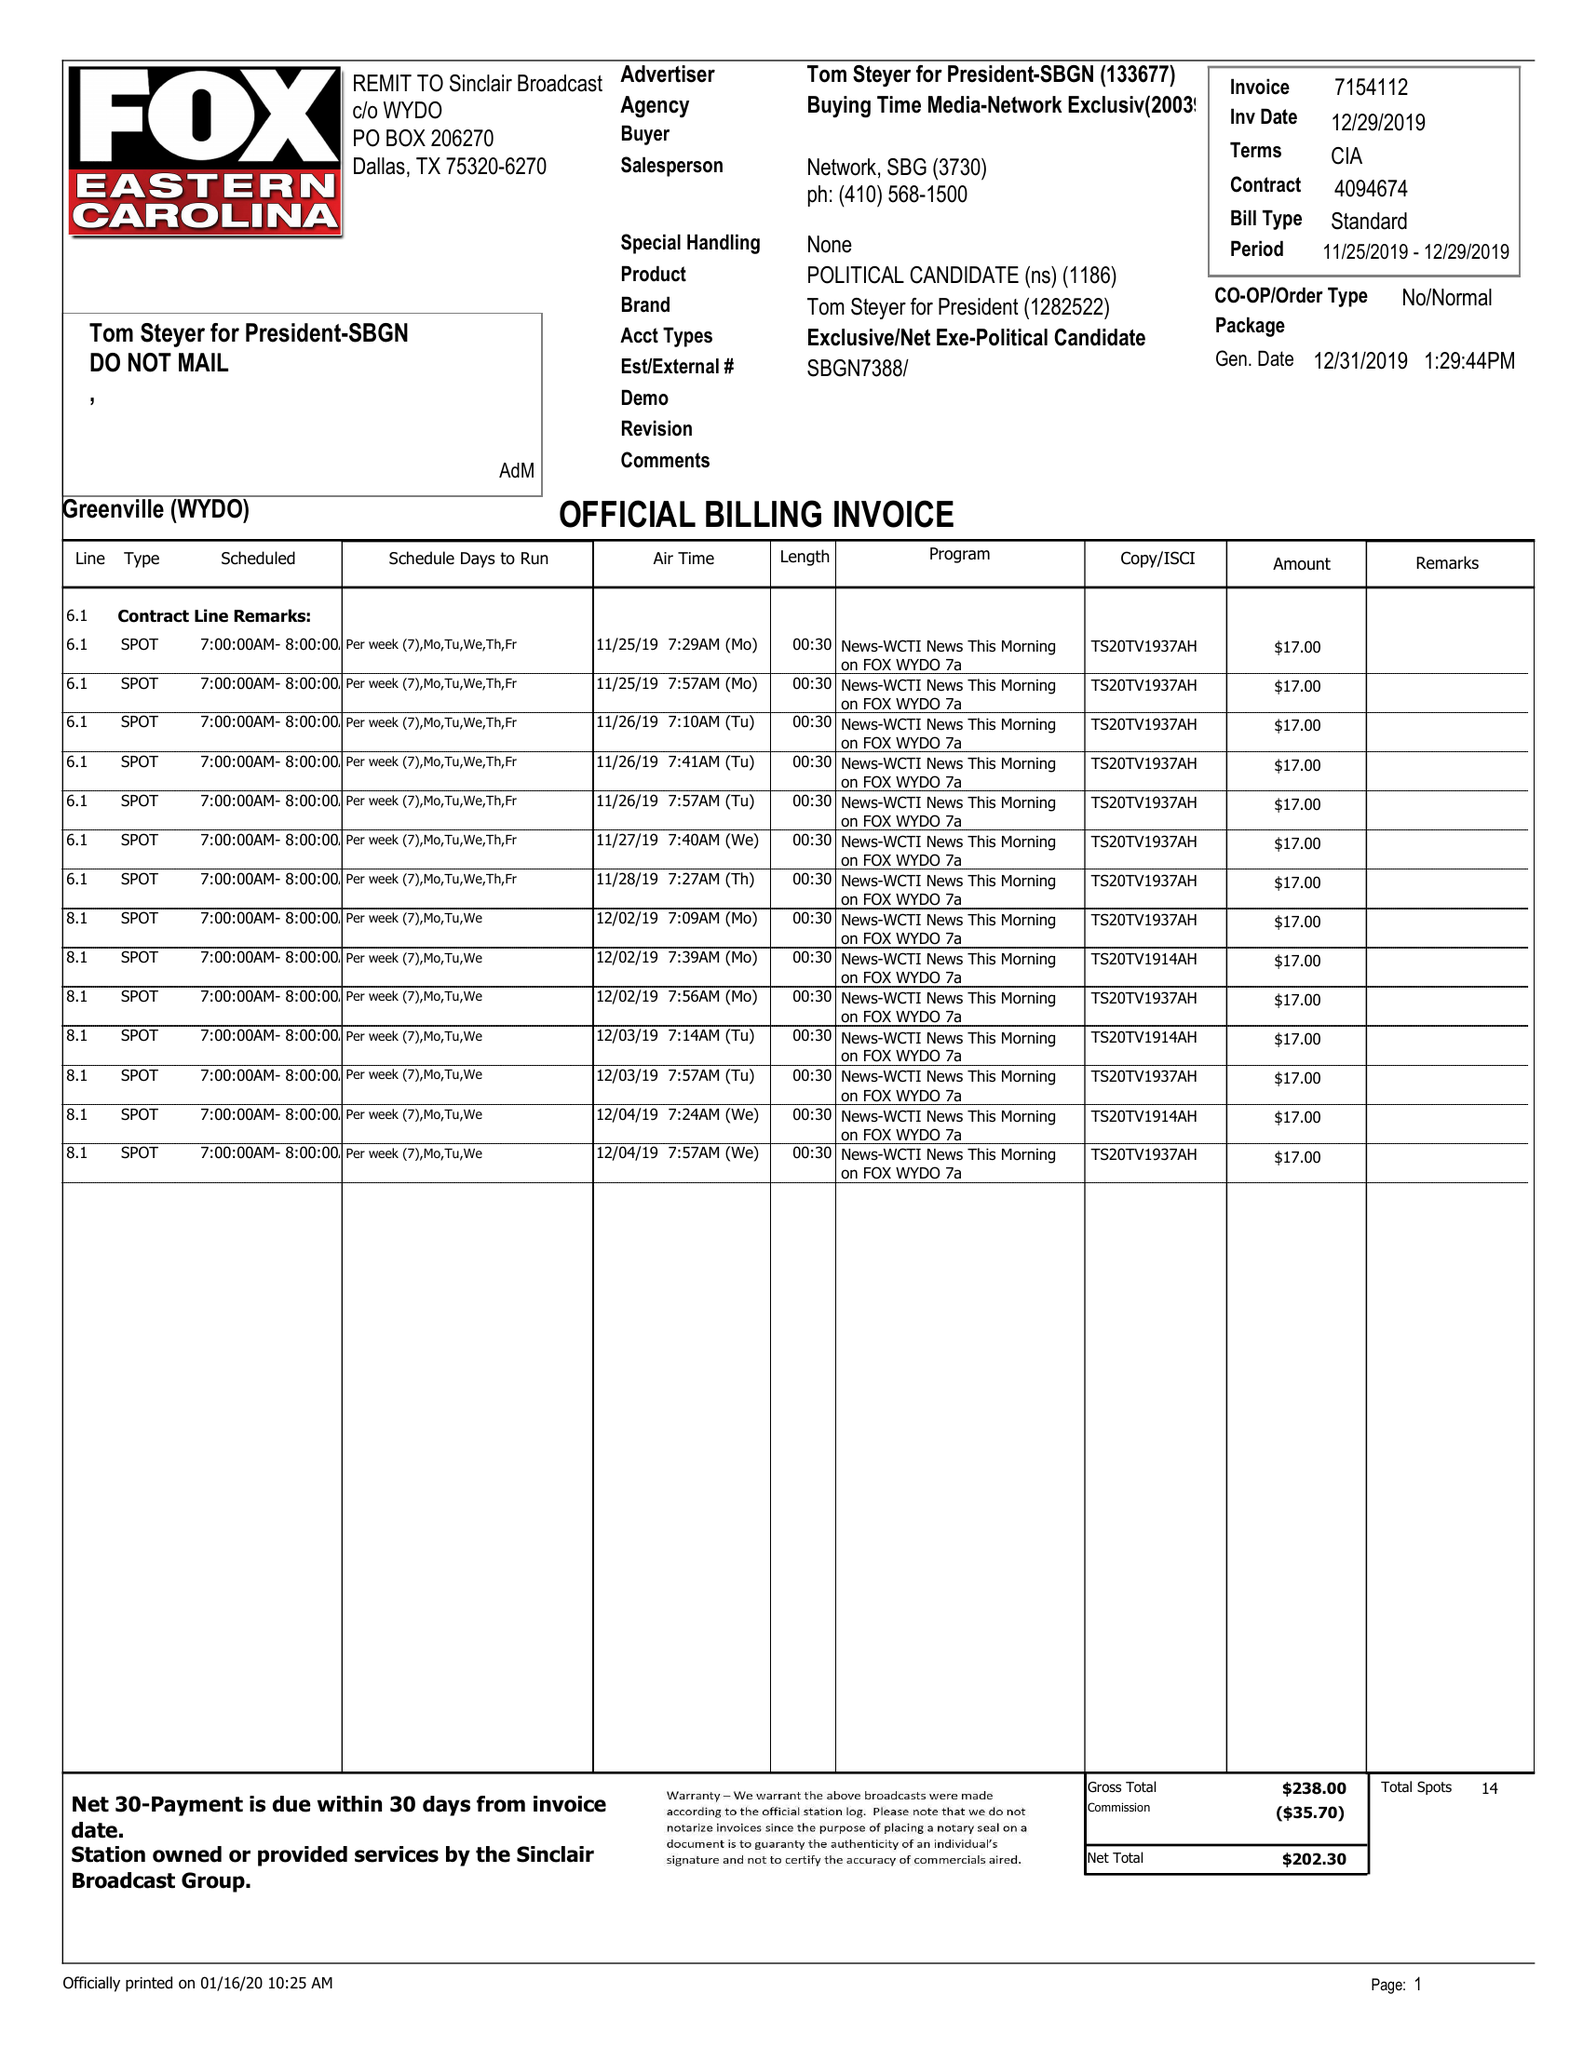What is the value for the flight_from?
Answer the question using a single word or phrase. 11/25/20 